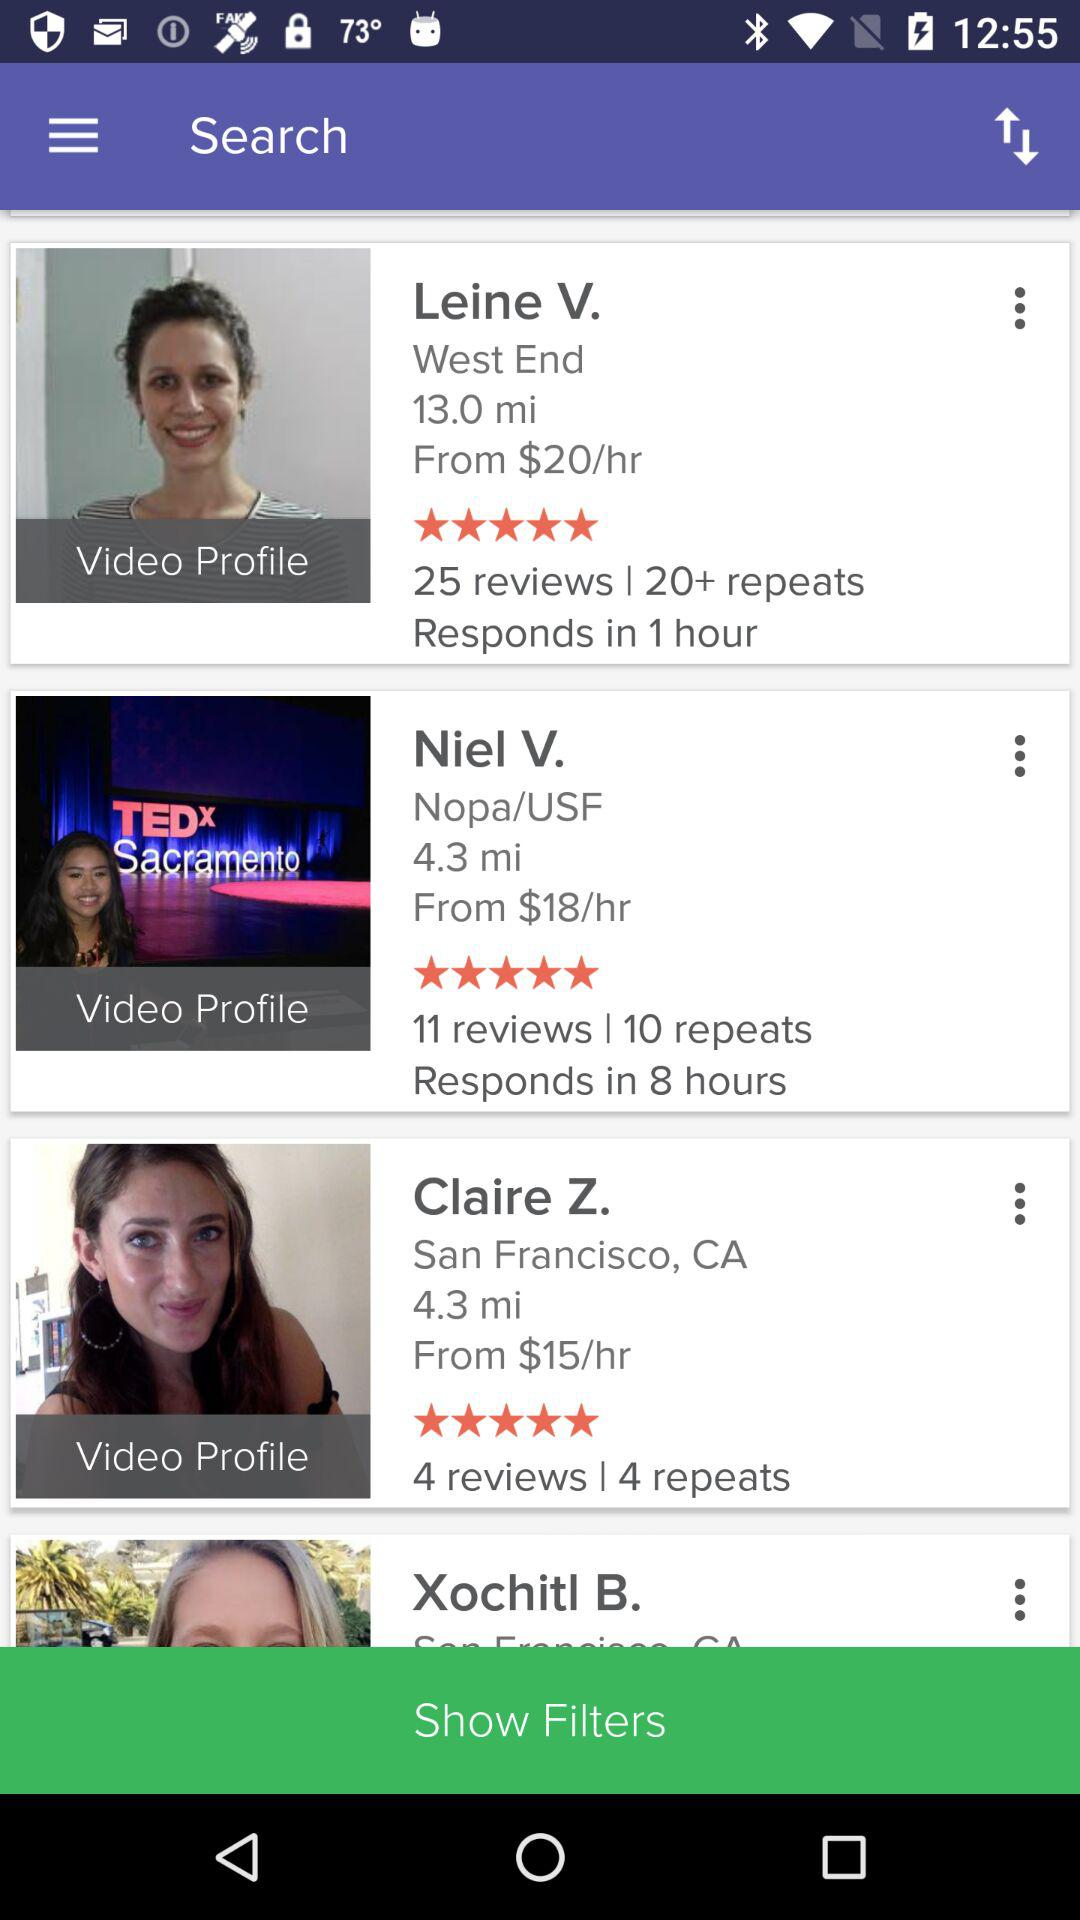In how many hours does Niel V. respond? Niel V. responds in 8 hours. 